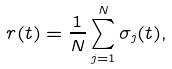<formula> <loc_0><loc_0><loc_500><loc_500>r ( t ) = \frac { 1 } { N } \sum _ { j = 1 } ^ { N } \sigma _ { j } ( t ) ,</formula> 